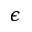<formula> <loc_0><loc_0><loc_500><loc_500>\epsilon</formula> 